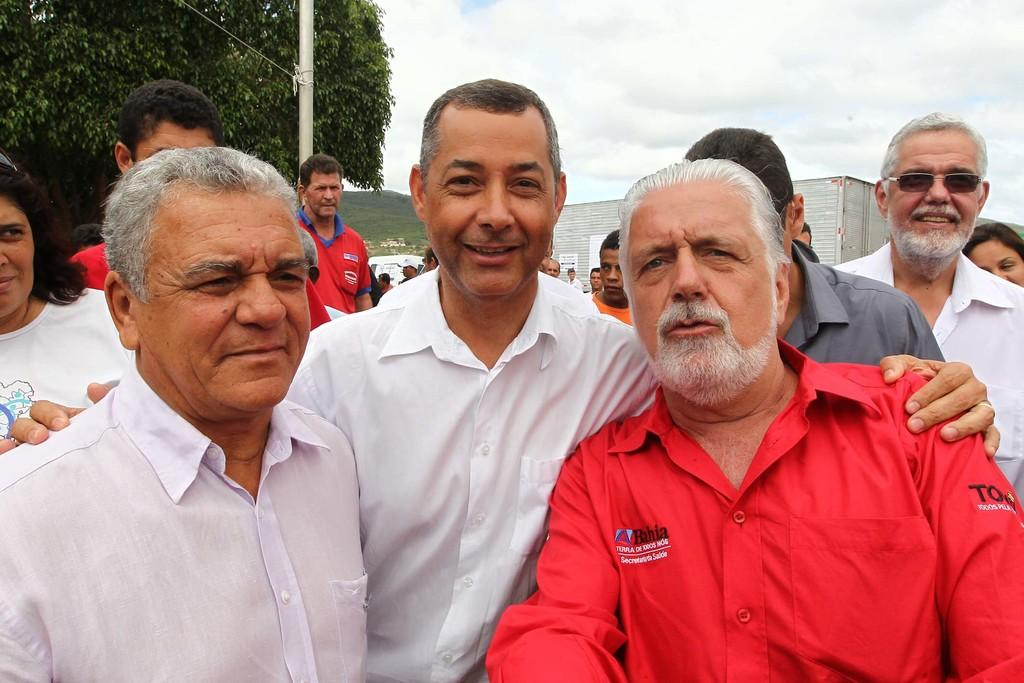What are the people in the image doing? The people in the image are taking pictures. Can you describe the background of the image? There are people and trees visible in the background of the image. What else can be seen in the background of the image? Vehicles are present in the background of the image. What type of garden can be seen in the image? There is no garden present in the image. What fictional character is interacting with the people taking pictures in the image? There are no fictional characters present in the image. 